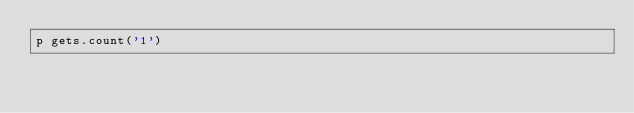Convert code to text. <code><loc_0><loc_0><loc_500><loc_500><_Ruby_>p gets.count('1')</code> 